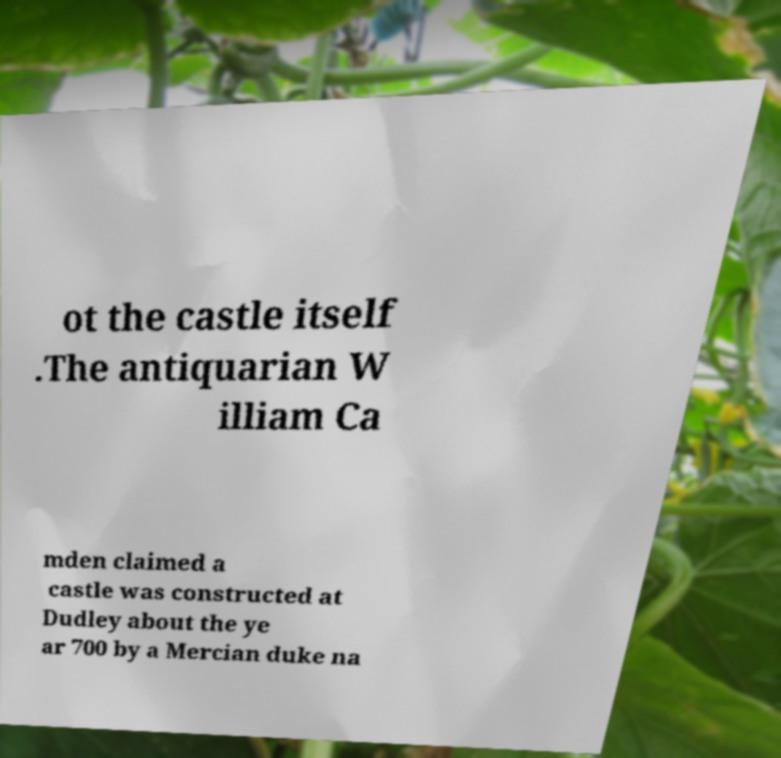For documentation purposes, I need the text within this image transcribed. Could you provide that? ot the castle itself .The antiquarian W illiam Ca mden claimed a castle was constructed at Dudley about the ye ar 700 by a Mercian duke na 